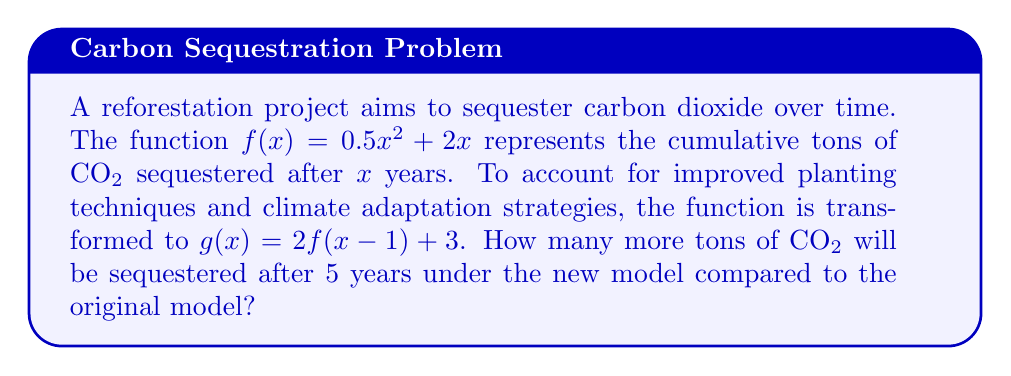Show me your answer to this math problem. 1) First, let's calculate the CO₂ sequestered after 5 years using the original function $f(x)$:
   $f(5) = 0.5(5)^2 + 2(5) = 0.5(25) + 10 = 12.5 + 10 = 22.5$ tons

2) Now, let's calculate using the transformed function $g(x)$:
   $g(x) = 2f(x-1) + 3$
   $g(5) = 2f(5-1) + 3 = 2f(4) + 3$

3) Calculate $f(4)$:
   $f(4) = 0.5(4)^2 + 2(4) = 0.5(16) + 8 = 8 + 8 = 16$ tons

4) Now we can complete the calculation for $g(5)$:
   $g(5) = 2(16) + 3 = 32 + 3 = 35$ tons

5) To find the difference, subtract the result of $f(5)$ from $g(5)$:
   $35 - 22.5 = 12.5$ tons

Therefore, the new model predicts 12.5 more tons of CO₂ will be sequestered after 5 years compared to the original model.
Answer: 12.5 tons 